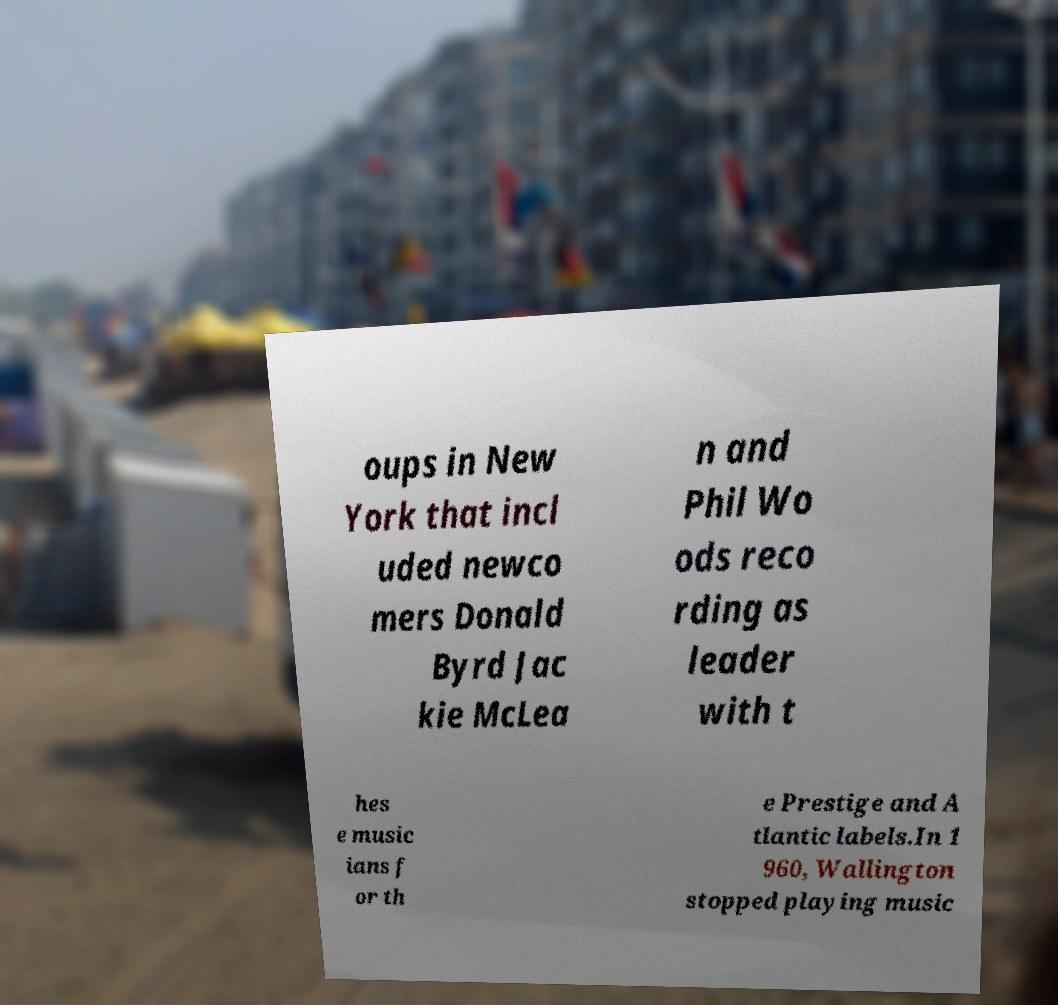There's text embedded in this image that I need extracted. Can you transcribe it verbatim? oups in New York that incl uded newco mers Donald Byrd Jac kie McLea n and Phil Wo ods reco rding as leader with t hes e music ians f or th e Prestige and A tlantic labels.In 1 960, Wallington stopped playing music 